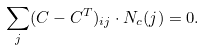<formula> <loc_0><loc_0><loc_500><loc_500>\sum _ { j } ( C - C ^ { T } ) _ { i j } \cdot N _ { c } ( j ) = 0 .</formula> 